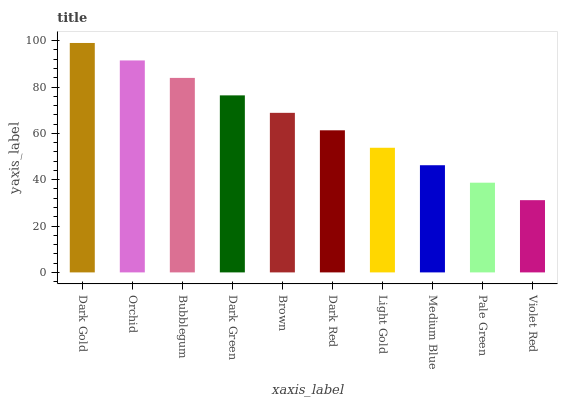Is Violet Red the minimum?
Answer yes or no. Yes. Is Dark Gold the maximum?
Answer yes or no. Yes. Is Orchid the minimum?
Answer yes or no. No. Is Orchid the maximum?
Answer yes or no. No. Is Dark Gold greater than Orchid?
Answer yes or no. Yes. Is Orchid less than Dark Gold?
Answer yes or no. Yes. Is Orchid greater than Dark Gold?
Answer yes or no. No. Is Dark Gold less than Orchid?
Answer yes or no. No. Is Brown the high median?
Answer yes or no. Yes. Is Dark Red the low median?
Answer yes or no. Yes. Is Light Gold the high median?
Answer yes or no. No. Is Orchid the low median?
Answer yes or no. No. 